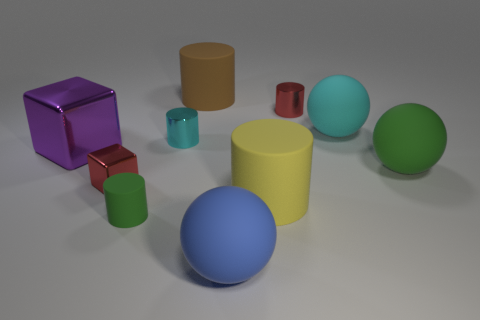Are there fewer big cyan things behind the red cylinder than small cyan rubber cylinders?
Offer a very short reply. No. Do the red thing that is on the left side of the tiny cyan object and the small cyan metallic thing have the same shape?
Make the answer very short. No. Is there anything else of the same color as the big metallic object?
Give a very brief answer. No. What size is the blue ball that is made of the same material as the large brown cylinder?
Keep it short and to the point. Large. There is a large cylinder that is behind the cyan shiny cylinder behind the rubber ball in front of the tiny rubber cylinder; what is it made of?
Your response must be concise. Rubber. Are there fewer green things than large gray shiny cubes?
Give a very brief answer. No. Does the large brown object have the same material as the green cylinder?
Provide a succinct answer. Yes. There is a small thing that is the same color as the small block; what is its shape?
Keep it short and to the point. Cylinder. Do the metallic object to the right of the big blue rubber ball and the small block have the same color?
Keep it short and to the point. Yes. How many shiny cylinders are left of the matte cylinder that is behind the red cylinder?
Your answer should be compact. 1. 